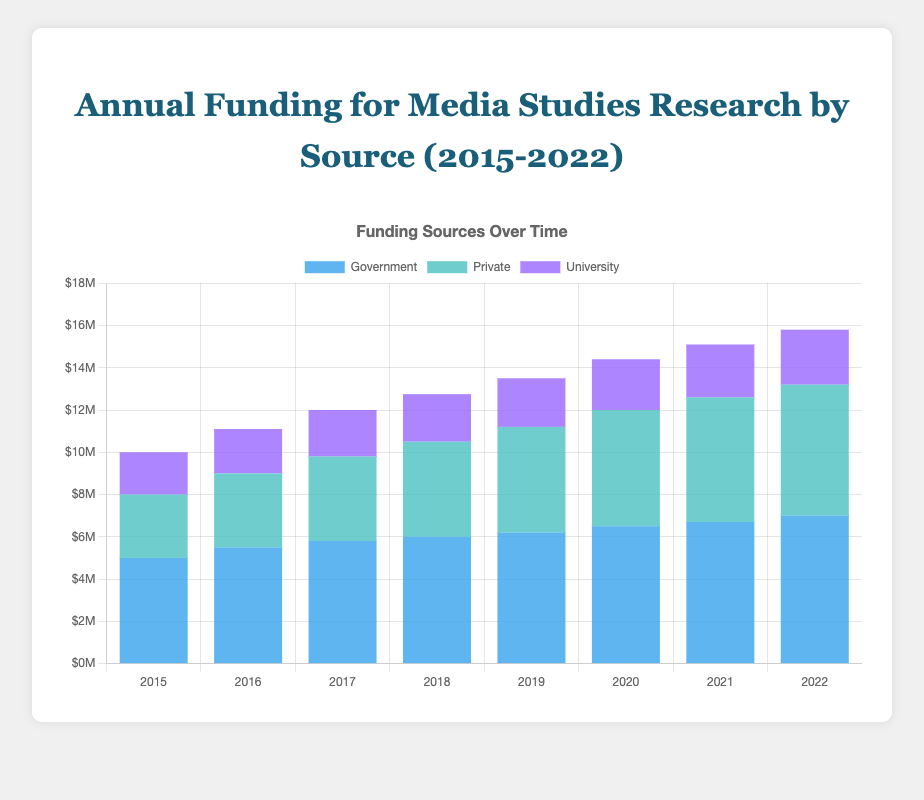What was the total funding provided for Media Studies Research in 2020 from all sources? Add the amounts from Government, Private, and University sources for 2020: $6,500,000 (Government) + $5,500,000 (Private) + $2,400,000 (University) = $14,400,000.
Answer: $14,400,000 Which source provided the most funding each year from 2015 to 2022? For each year, compare the funding amounts from Government, Private, and University sources. The Government source consistently provides the highest funding each year.
Answer: Government By how much did Private funding increase from 2015 to 2022? Subtract the Private funding amount of 2015 from the amount of 2022: $6,200,000 (2022) - $3,000,000 (2015) = $3,200,000.
Answer: $3,200,000 During which year did the total funding for Media Studies Research first exceed $15,000,000? Add the funding amounts from all sources each year until the total exceeds $15,000,000: In 2022, the total is $7,000,000 (Government) + $6,200,000 (Private) + $2,600,000 (University) = $15,800,000.
Answer: 2022 What trend can be seen in University funding from 2015 to 2022? Observe the University funding amounts each year to identify the trend: University funding increased steadily from $2,000,000 in 2015 to $2,600,000 in 2022.
Answer: It steadily increased How much more funding did Government sources provide compared to University sources in 2021? Subtract the University funding from the Government funding for 2021: $6,700,000 (Government) - $2,500,000 (University) = $4,200,000.
Answer: $4,200,000 Which year saw the largest increase in Government funding compared to the previous year? Calculate the year-over-year increase for Government funding and identify the largest: The largest increase was between 2019 and 2020 where Government funding jumped from $6,200,000 to $6,500,000, an increase of $300,000.
Answer: 2020 Compare the total funding for Media Studies Research between 2018 and 2022. Calculate the sum of the funding from all sources for 2018 and 2022: 2018 total = $6,000,000 (Government) + $4,500,000 (Private) + $2,250,000 (University) = $12,750,000. 2022 total = $7,000,000 (Government) + $6,200,000 (Private) + $2,600,000 (University) = $15,800,000. Compare the two totals: $15,800,000 (2022) - $12,750,000 (2018) = $3,050,000.
Answer: $3,050,000 more in 2022 Is there any year where University funding decreased compared to the previous year? Observe the University funding amounts year over year to check for any decrease: University funding did not decrease in any year between 2015 and 2022; it increased or remained stable every year.
Answer: No 